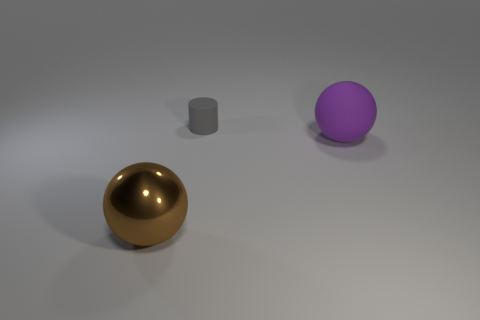Are there any other things that are the same size as the rubber cylinder?
Give a very brief answer. No. Does the gray object on the left side of the large rubber sphere have the same material as the large thing to the left of the gray cylinder?
Ensure brevity in your answer.  No. How many things are large objects to the right of the big brown metallic ball or big objects that are behind the brown sphere?
Provide a succinct answer. 1. Is there any other thing that has the same shape as the small gray thing?
Your answer should be very brief. No. How many small gray things are there?
Provide a succinct answer. 1. Is there another ball of the same size as the purple sphere?
Offer a terse response. Yes. Is the material of the gray thing the same as the large thing that is to the left of the purple matte ball?
Keep it short and to the point. No. What material is the object that is behind the large purple ball?
Give a very brief answer. Rubber. What is the size of the gray cylinder?
Your answer should be very brief. Small. Does the sphere to the right of the large brown shiny sphere have the same size as the thing behind the big purple matte sphere?
Offer a very short reply. No. 